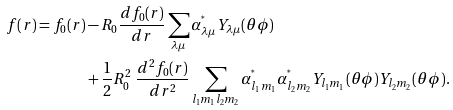Convert formula to latex. <formula><loc_0><loc_0><loc_500><loc_500>f ( r ) = f _ { 0 } ( r ) & - R _ { 0 } \frac { d f _ { 0 } ( r ) } { d r } \sum _ { \lambda \mu } \alpha _ { \lambda \mu } ^ { ^ { * } } Y _ { \lambda \mu } ( \theta \phi ) \\ & + \frac { 1 } { 2 } R _ { 0 } ^ { 2 } \ \frac { d ^ { 2 } f _ { 0 } ( r ) } { d r ^ { 2 } } \sum _ { l _ { 1 } m _ { 1 } l _ { 2 } m _ { 2 } } \alpha _ { l _ { 1 } m _ { 1 } } ^ { ^ { * } } \alpha _ { l _ { 2 } m _ { 2 } } ^ { ^ { * } } Y _ { l _ { 1 } m _ { 1 } } ( \theta \phi ) Y _ { l _ { 2 } m _ { 2 } } ( \theta \phi ) .</formula> 